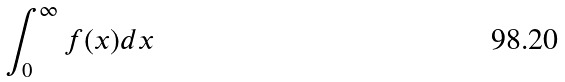<formula> <loc_0><loc_0><loc_500><loc_500>\int _ { 0 } ^ { \infty } f ( x ) d x</formula> 